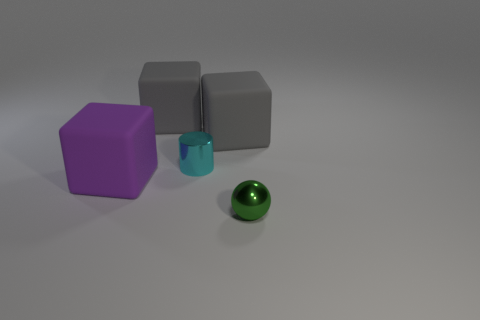Are there any green blocks that have the same size as the cyan thing?
Keep it short and to the point. No. The green object that is the same size as the cyan thing is what shape?
Give a very brief answer. Sphere. Are there any other large things that have the same shape as the cyan metal thing?
Provide a succinct answer. No. Are the small green sphere and the big gray object that is on the right side of the cylinder made of the same material?
Your answer should be very brief. No. Is there a small thing that has the same color as the small sphere?
Make the answer very short. No. How many other objects are the same material as the tiny cyan object?
Keep it short and to the point. 1. There is a small metallic cylinder; does it have the same color as the small shiny object that is right of the tiny cylinder?
Offer a terse response. No. Are there more tiny green metal spheres that are behind the small green shiny ball than small gray metallic blocks?
Give a very brief answer. No. There is a shiny cylinder that is to the left of the small green object that is in front of the purple object; how many tiny shiny cylinders are on the left side of it?
Make the answer very short. 0. There is a rubber object in front of the tiny cyan cylinder; does it have the same shape as the green metallic object?
Provide a short and direct response. No. 